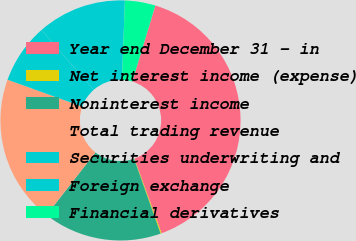Convert chart. <chart><loc_0><loc_0><loc_500><loc_500><pie_chart><fcel>Year end December 31 - in<fcel>Net interest income (expense)<fcel>Noninterest income<fcel>Total trading revenue<fcel>Securities underwriting and<fcel>Foreign exchange<fcel>Financial derivatives<nl><fcel>39.75%<fcel>0.14%<fcel>15.98%<fcel>19.94%<fcel>8.06%<fcel>12.02%<fcel>4.1%<nl></chart> 